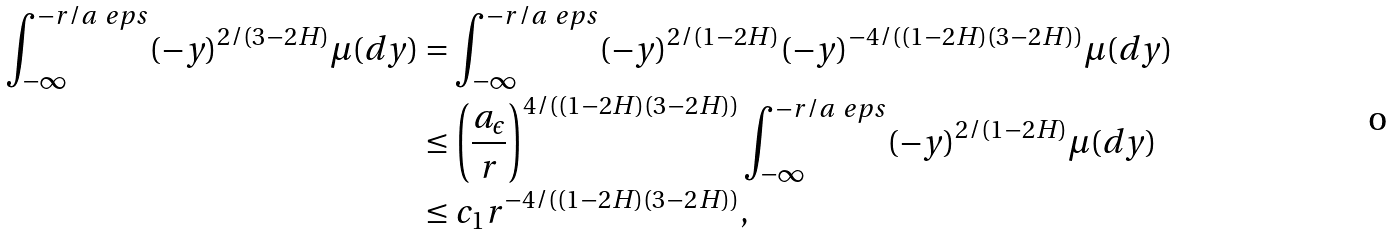<formula> <loc_0><loc_0><loc_500><loc_500>\int _ { - \infty } ^ { - r / a _ { \ } e p s } ( - y ) ^ { 2 / ( 3 - 2 H ) } \mu ( d y ) & = \int _ { - \infty } ^ { - r / a _ { \ } e p s } ( - y ) ^ { 2 / ( 1 - 2 H ) } ( - y ) ^ { - 4 / ( ( 1 - 2 H ) ( 3 - 2 H ) ) } \mu ( d y ) \\ & \leq \left ( \frac { a _ { \epsilon } } { r } \right ) ^ { 4 / ( ( 1 - 2 H ) ( 3 - 2 H ) ) } \int _ { - \infty } ^ { - r / a _ { \ } e p s } ( - y ) ^ { 2 / ( 1 - 2 H ) } \mu ( d y ) \\ & \leq c _ { 1 } r ^ { - 4 / ( ( 1 - 2 H ) ( 3 - 2 H ) ) } ,</formula> 